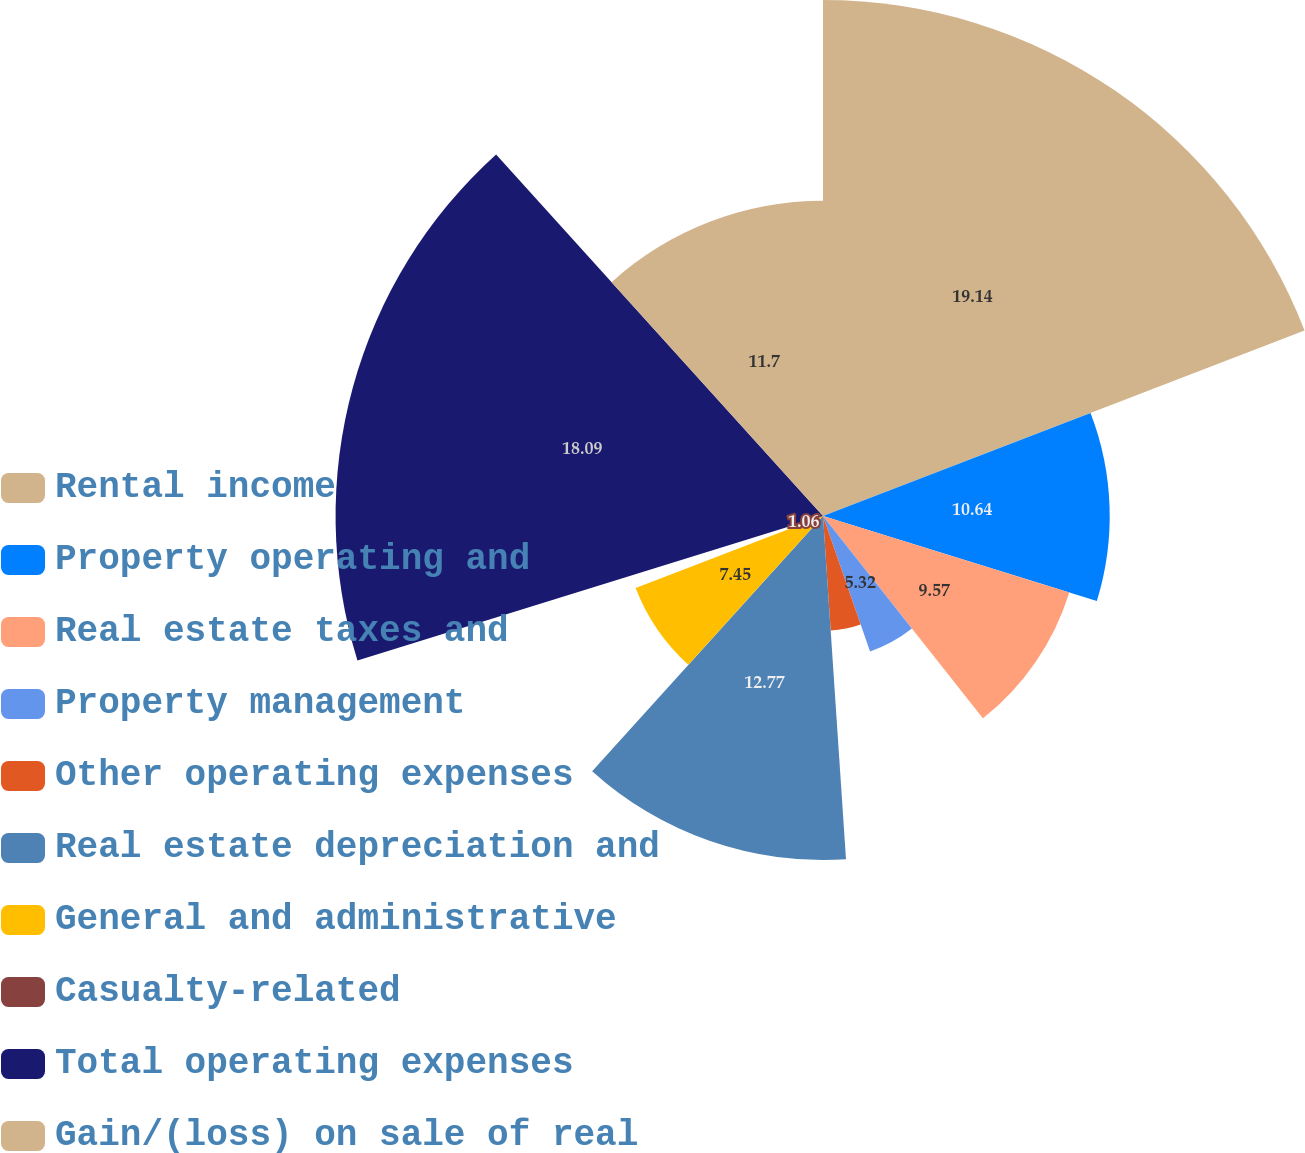Convert chart to OTSL. <chart><loc_0><loc_0><loc_500><loc_500><pie_chart><fcel>Rental income<fcel>Property operating and<fcel>Real estate taxes and<fcel>Property management<fcel>Other operating expenses<fcel>Real estate depreciation and<fcel>General and administrative<fcel>Casualty-related<fcel>Total operating expenses<fcel>Gain/(loss) on sale of real<nl><fcel>19.15%<fcel>10.64%<fcel>9.57%<fcel>5.32%<fcel>4.26%<fcel>12.77%<fcel>7.45%<fcel>1.06%<fcel>18.09%<fcel>11.7%<nl></chart> 